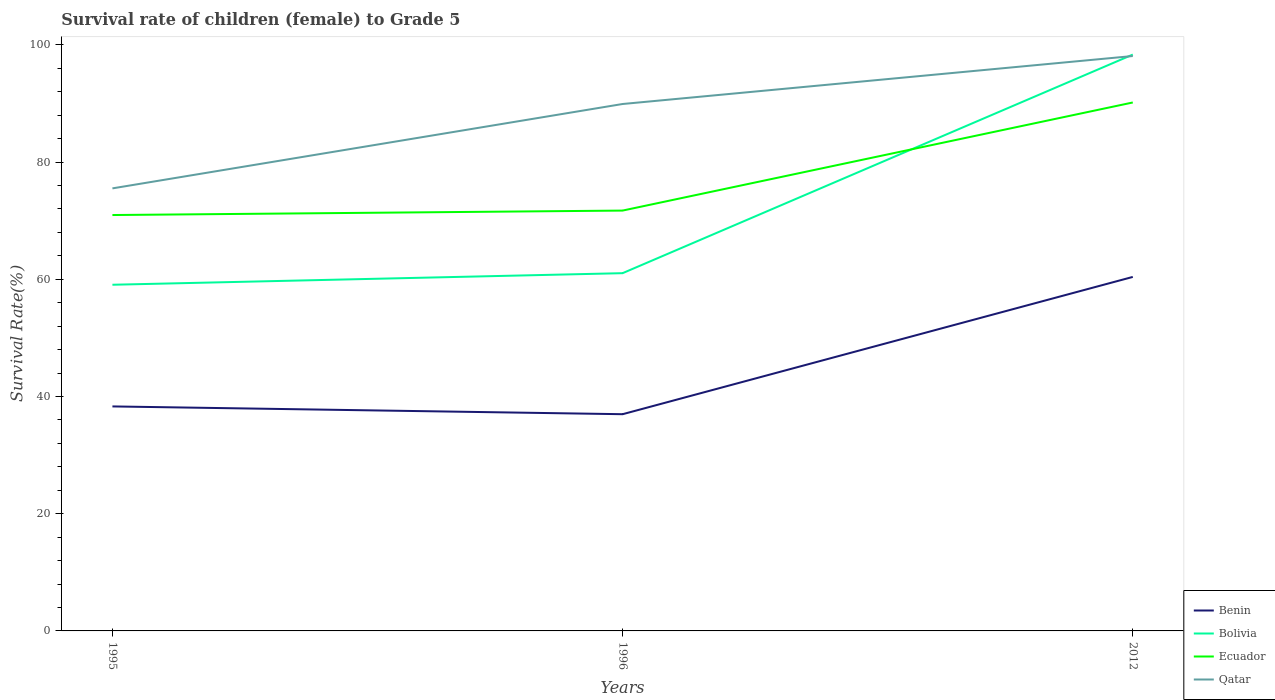Does the line corresponding to Bolivia intersect with the line corresponding to Qatar?
Your answer should be compact. Yes. Is the number of lines equal to the number of legend labels?
Make the answer very short. Yes. Across all years, what is the maximum survival rate of female children to grade 5 in Qatar?
Ensure brevity in your answer.  75.52. What is the total survival rate of female children to grade 5 in Ecuador in the graph?
Your answer should be compact. -18.45. What is the difference between the highest and the second highest survival rate of female children to grade 5 in Bolivia?
Give a very brief answer. 39.28. What is the difference between the highest and the lowest survival rate of female children to grade 5 in Benin?
Provide a short and direct response. 1. How many lines are there?
Your answer should be very brief. 4. What is the difference between two consecutive major ticks on the Y-axis?
Your answer should be very brief. 20. Are the values on the major ticks of Y-axis written in scientific E-notation?
Provide a succinct answer. No. Does the graph contain any zero values?
Offer a terse response. No. How many legend labels are there?
Offer a very short reply. 4. What is the title of the graph?
Provide a short and direct response. Survival rate of children (female) to Grade 5. Does "Bangladesh" appear as one of the legend labels in the graph?
Your answer should be compact. No. What is the label or title of the Y-axis?
Your answer should be compact. Survival Rate(%). What is the Survival Rate(%) of Benin in 1995?
Provide a succinct answer. 38.31. What is the Survival Rate(%) of Bolivia in 1995?
Your answer should be compact. 59.07. What is the Survival Rate(%) of Ecuador in 1995?
Provide a succinct answer. 70.97. What is the Survival Rate(%) in Qatar in 1995?
Your response must be concise. 75.52. What is the Survival Rate(%) in Benin in 1996?
Your response must be concise. 36.98. What is the Survival Rate(%) in Bolivia in 1996?
Keep it short and to the point. 61.05. What is the Survival Rate(%) in Ecuador in 1996?
Offer a terse response. 71.73. What is the Survival Rate(%) of Qatar in 1996?
Offer a very short reply. 89.92. What is the Survival Rate(%) of Benin in 2012?
Your answer should be very brief. 60.41. What is the Survival Rate(%) of Bolivia in 2012?
Provide a succinct answer. 98.35. What is the Survival Rate(%) in Ecuador in 2012?
Offer a very short reply. 90.18. What is the Survival Rate(%) of Qatar in 2012?
Your response must be concise. 98.1. Across all years, what is the maximum Survival Rate(%) in Benin?
Offer a terse response. 60.41. Across all years, what is the maximum Survival Rate(%) in Bolivia?
Ensure brevity in your answer.  98.35. Across all years, what is the maximum Survival Rate(%) of Ecuador?
Keep it short and to the point. 90.18. Across all years, what is the maximum Survival Rate(%) of Qatar?
Your response must be concise. 98.1. Across all years, what is the minimum Survival Rate(%) of Benin?
Give a very brief answer. 36.98. Across all years, what is the minimum Survival Rate(%) of Bolivia?
Offer a very short reply. 59.07. Across all years, what is the minimum Survival Rate(%) in Ecuador?
Offer a terse response. 70.97. Across all years, what is the minimum Survival Rate(%) in Qatar?
Ensure brevity in your answer.  75.52. What is the total Survival Rate(%) of Benin in the graph?
Ensure brevity in your answer.  135.7. What is the total Survival Rate(%) of Bolivia in the graph?
Your answer should be very brief. 218.47. What is the total Survival Rate(%) in Ecuador in the graph?
Your answer should be very brief. 232.88. What is the total Survival Rate(%) in Qatar in the graph?
Give a very brief answer. 263.54. What is the difference between the Survival Rate(%) in Benin in 1995 and that in 1996?
Provide a succinct answer. 1.33. What is the difference between the Survival Rate(%) in Bolivia in 1995 and that in 1996?
Provide a short and direct response. -1.98. What is the difference between the Survival Rate(%) of Ecuador in 1995 and that in 1996?
Make the answer very short. -0.76. What is the difference between the Survival Rate(%) in Qatar in 1995 and that in 1996?
Make the answer very short. -14.4. What is the difference between the Survival Rate(%) of Benin in 1995 and that in 2012?
Provide a short and direct response. -22.1. What is the difference between the Survival Rate(%) in Bolivia in 1995 and that in 2012?
Make the answer very short. -39.28. What is the difference between the Survival Rate(%) in Ecuador in 1995 and that in 2012?
Give a very brief answer. -19.21. What is the difference between the Survival Rate(%) in Qatar in 1995 and that in 2012?
Give a very brief answer. -22.59. What is the difference between the Survival Rate(%) of Benin in 1996 and that in 2012?
Offer a terse response. -23.43. What is the difference between the Survival Rate(%) of Bolivia in 1996 and that in 2012?
Provide a succinct answer. -37.3. What is the difference between the Survival Rate(%) in Ecuador in 1996 and that in 2012?
Keep it short and to the point. -18.45. What is the difference between the Survival Rate(%) in Qatar in 1996 and that in 2012?
Provide a succinct answer. -8.19. What is the difference between the Survival Rate(%) in Benin in 1995 and the Survival Rate(%) in Bolivia in 1996?
Your answer should be very brief. -22.74. What is the difference between the Survival Rate(%) of Benin in 1995 and the Survival Rate(%) of Ecuador in 1996?
Provide a short and direct response. -33.42. What is the difference between the Survival Rate(%) in Benin in 1995 and the Survival Rate(%) in Qatar in 1996?
Give a very brief answer. -51.61. What is the difference between the Survival Rate(%) of Bolivia in 1995 and the Survival Rate(%) of Ecuador in 1996?
Offer a very short reply. -12.66. What is the difference between the Survival Rate(%) in Bolivia in 1995 and the Survival Rate(%) in Qatar in 1996?
Keep it short and to the point. -30.84. What is the difference between the Survival Rate(%) in Ecuador in 1995 and the Survival Rate(%) in Qatar in 1996?
Provide a short and direct response. -18.95. What is the difference between the Survival Rate(%) in Benin in 1995 and the Survival Rate(%) in Bolivia in 2012?
Keep it short and to the point. -60.04. What is the difference between the Survival Rate(%) in Benin in 1995 and the Survival Rate(%) in Ecuador in 2012?
Offer a terse response. -51.87. What is the difference between the Survival Rate(%) in Benin in 1995 and the Survival Rate(%) in Qatar in 2012?
Offer a very short reply. -59.79. What is the difference between the Survival Rate(%) in Bolivia in 1995 and the Survival Rate(%) in Ecuador in 2012?
Ensure brevity in your answer.  -31.1. What is the difference between the Survival Rate(%) of Bolivia in 1995 and the Survival Rate(%) of Qatar in 2012?
Ensure brevity in your answer.  -39.03. What is the difference between the Survival Rate(%) of Ecuador in 1995 and the Survival Rate(%) of Qatar in 2012?
Ensure brevity in your answer.  -27.13. What is the difference between the Survival Rate(%) of Benin in 1996 and the Survival Rate(%) of Bolivia in 2012?
Provide a short and direct response. -61.37. What is the difference between the Survival Rate(%) of Benin in 1996 and the Survival Rate(%) of Ecuador in 2012?
Offer a terse response. -53.2. What is the difference between the Survival Rate(%) in Benin in 1996 and the Survival Rate(%) in Qatar in 2012?
Your answer should be very brief. -61.12. What is the difference between the Survival Rate(%) in Bolivia in 1996 and the Survival Rate(%) in Ecuador in 2012?
Provide a succinct answer. -29.13. What is the difference between the Survival Rate(%) of Bolivia in 1996 and the Survival Rate(%) of Qatar in 2012?
Give a very brief answer. -37.05. What is the difference between the Survival Rate(%) in Ecuador in 1996 and the Survival Rate(%) in Qatar in 2012?
Keep it short and to the point. -26.37. What is the average Survival Rate(%) in Benin per year?
Your answer should be compact. 45.23. What is the average Survival Rate(%) in Bolivia per year?
Offer a terse response. 72.82. What is the average Survival Rate(%) of Ecuador per year?
Offer a terse response. 77.63. What is the average Survival Rate(%) in Qatar per year?
Provide a succinct answer. 87.85. In the year 1995, what is the difference between the Survival Rate(%) of Benin and Survival Rate(%) of Bolivia?
Make the answer very short. -20.76. In the year 1995, what is the difference between the Survival Rate(%) of Benin and Survival Rate(%) of Ecuador?
Your answer should be compact. -32.66. In the year 1995, what is the difference between the Survival Rate(%) in Benin and Survival Rate(%) in Qatar?
Your answer should be very brief. -37.21. In the year 1995, what is the difference between the Survival Rate(%) of Bolivia and Survival Rate(%) of Ecuador?
Offer a very short reply. -11.9. In the year 1995, what is the difference between the Survival Rate(%) of Bolivia and Survival Rate(%) of Qatar?
Give a very brief answer. -16.45. In the year 1995, what is the difference between the Survival Rate(%) in Ecuador and Survival Rate(%) in Qatar?
Your answer should be compact. -4.55. In the year 1996, what is the difference between the Survival Rate(%) in Benin and Survival Rate(%) in Bolivia?
Offer a very short reply. -24.07. In the year 1996, what is the difference between the Survival Rate(%) of Benin and Survival Rate(%) of Ecuador?
Your answer should be compact. -34.75. In the year 1996, what is the difference between the Survival Rate(%) in Benin and Survival Rate(%) in Qatar?
Keep it short and to the point. -52.94. In the year 1996, what is the difference between the Survival Rate(%) in Bolivia and Survival Rate(%) in Ecuador?
Give a very brief answer. -10.68. In the year 1996, what is the difference between the Survival Rate(%) of Bolivia and Survival Rate(%) of Qatar?
Your answer should be very brief. -28.87. In the year 1996, what is the difference between the Survival Rate(%) in Ecuador and Survival Rate(%) in Qatar?
Give a very brief answer. -18.19. In the year 2012, what is the difference between the Survival Rate(%) of Benin and Survival Rate(%) of Bolivia?
Your answer should be very brief. -37.95. In the year 2012, what is the difference between the Survival Rate(%) in Benin and Survival Rate(%) in Ecuador?
Provide a short and direct response. -29.77. In the year 2012, what is the difference between the Survival Rate(%) in Benin and Survival Rate(%) in Qatar?
Give a very brief answer. -37.7. In the year 2012, what is the difference between the Survival Rate(%) of Bolivia and Survival Rate(%) of Ecuador?
Give a very brief answer. 8.18. In the year 2012, what is the difference between the Survival Rate(%) in Bolivia and Survival Rate(%) in Qatar?
Provide a succinct answer. 0.25. In the year 2012, what is the difference between the Survival Rate(%) in Ecuador and Survival Rate(%) in Qatar?
Offer a very short reply. -7.93. What is the ratio of the Survival Rate(%) of Benin in 1995 to that in 1996?
Ensure brevity in your answer.  1.04. What is the ratio of the Survival Rate(%) of Bolivia in 1995 to that in 1996?
Keep it short and to the point. 0.97. What is the ratio of the Survival Rate(%) of Qatar in 1995 to that in 1996?
Your answer should be compact. 0.84. What is the ratio of the Survival Rate(%) of Benin in 1995 to that in 2012?
Give a very brief answer. 0.63. What is the ratio of the Survival Rate(%) in Bolivia in 1995 to that in 2012?
Keep it short and to the point. 0.6. What is the ratio of the Survival Rate(%) of Ecuador in 1995 to that in 2012?
Give a very brief answer. 0.79. What is the ratio of the Survival Rate(%) in Qatar in 1995 to that in 2012?
Give a very brief answer. 0.77. What is the ratio of the Survival Rate(%) in Benin in 1996 to that in 2012?
Provide a succinct answer. 0.61. What is the ratio of the Survival Rate(%) of Bolivia in 1996 to that in 2012?
Your response must be concise. 0.62. What is the ratio of the Survival Rate(%) of Ecuador in 1996 to that in 2012?
Offer a very short reply. 0.8. What is the ratio of the Survival Rate(%) of Qatar in 1996 to that in 2012?
Offer a very short reply. 0.92. What is the difference between the highest and the second highest Survival Rate(%) in Benin?
Your answer should be very brief. 22.1. What is the difference between the highest and the second highest Survival Rate(%) of Bolivia?
Provide a short and direct response. 37.3. What is the difference between the highest and the second highest Survival Rate(%) of Ecuador?
Your answer should be compact. 18.45. What is the difference between the highest and the second highest Survival Rate(%) in Qatar?
Offer a very short reply. 8.19. What is the difference between the highest and the lowest Survival Rate(%) of Benin?
Ensure brevity in your answer.  23.43. What is the difference between the highest and the lowest Survival Rate(%) of Bolivia?
Offer a terse response. 39.28. What is the difference between the highest and the lowest Survival Rate(%) of Ecuador?
Ensure brevity in your answer.  19.21. What is the difference between the highest and the lowest Survival Rate(%) of Qatar?
Provide a succinct answer. 22.59. 